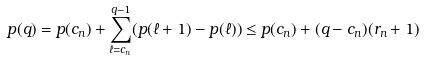<formula> <loc_0><loc_0><loc_500><loc_500>p ( q ) = p ( c _ { n } ) + \sum _ { \ell = c _ { n } } ^ { q - 1 } ( p ( \ell + 1 ) - p ( \ell ) ) \leq p ( c _ { n } ) + ( q - c _ { n } ) ( r _ { n } + 1 )</formula> 